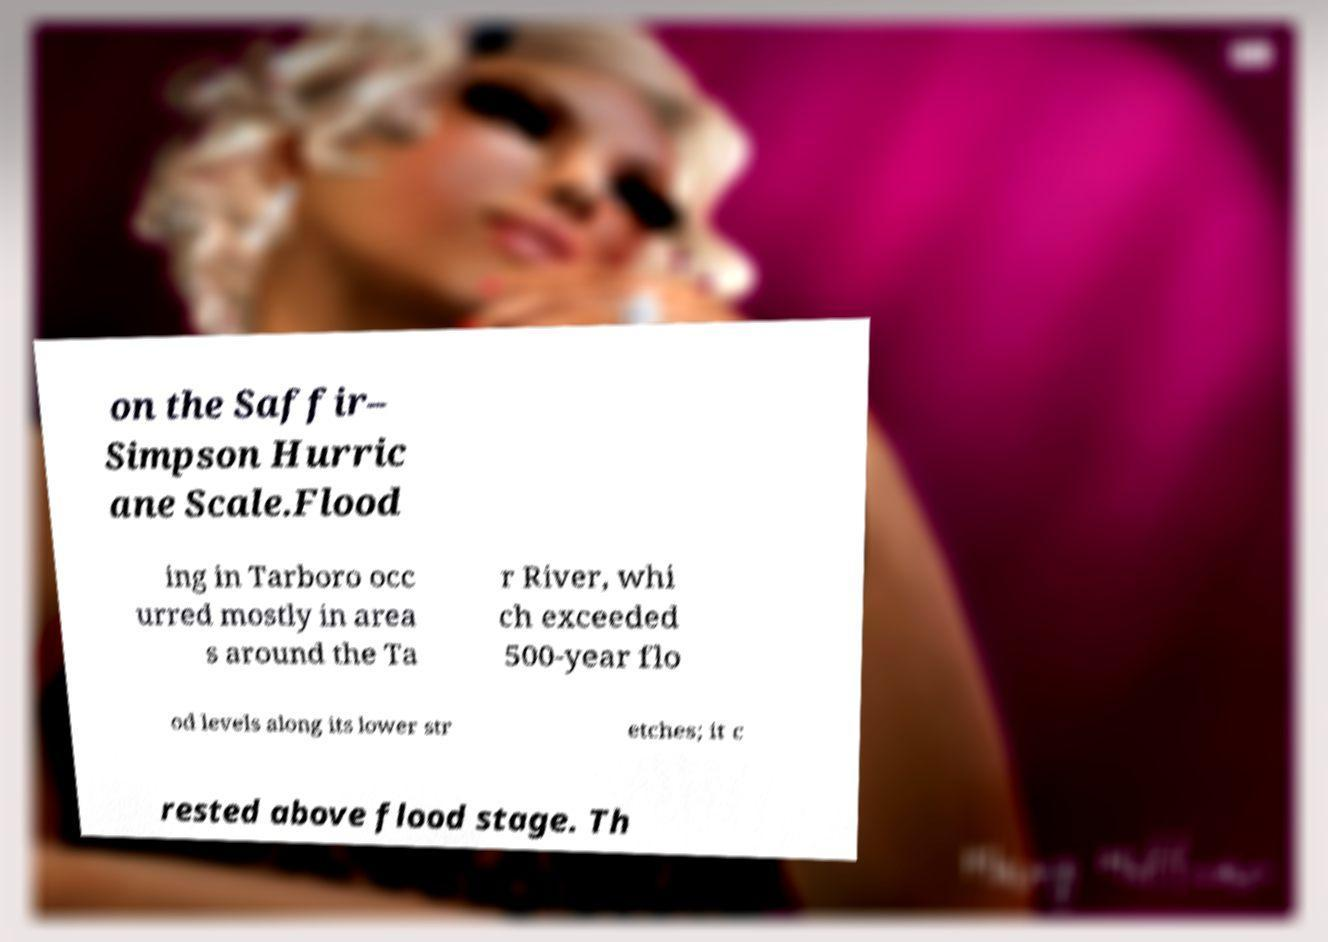There's text embedded in this image that I need extracted. Can you transcribe it verbatim? on the Saffir– Simpson Hurric ane Scale.Flood ing in Tarboro occ urred mostly in area s around the Ta r River, whi ch exceeded 500-year flo od levels along its lower str etches; it c rested above flood stage. Th 